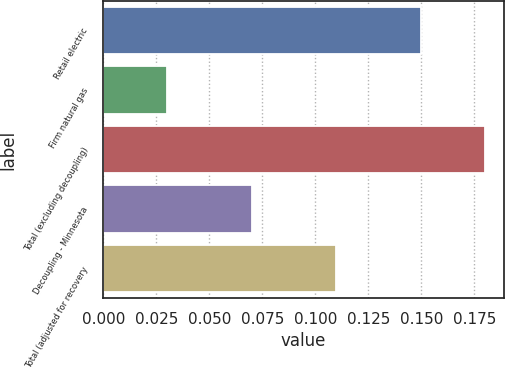Convert chart. <chart><loc_0><loc_0><loc_500><loc_500><bar_chart><fcel>Retail electric<fcel>Firm natural gas<fcel>Total (excluding decoupling)<fcel>Decoupling - Minnesota<fcel>Total (adjusted for recovery<nl><fcel>0.15<fcel>0.03<fcel>0.18<fcel>0.07<fcel>0.11<nl></chart> 